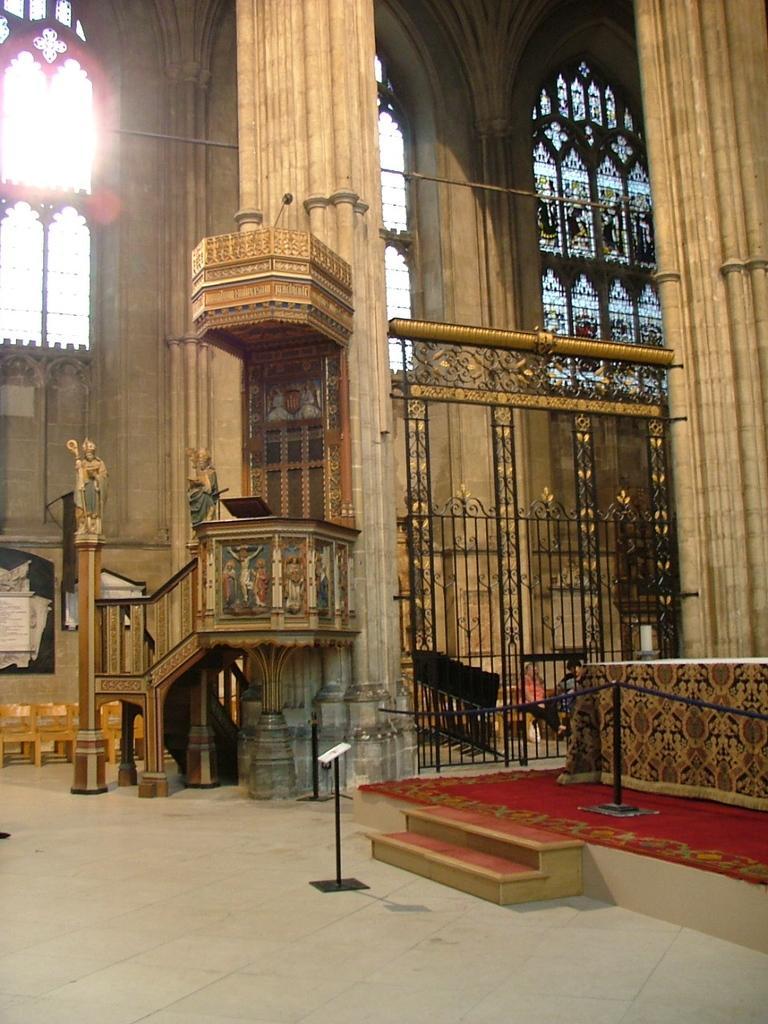In one or two sentences, can you explain what this image depicts? In this image I can see the ground, few black colored poles, two stairs, the railing , two huge pillars and few benches which are brown in color. In the background I can see the wall , few windows and through the windows I can see the sky. 